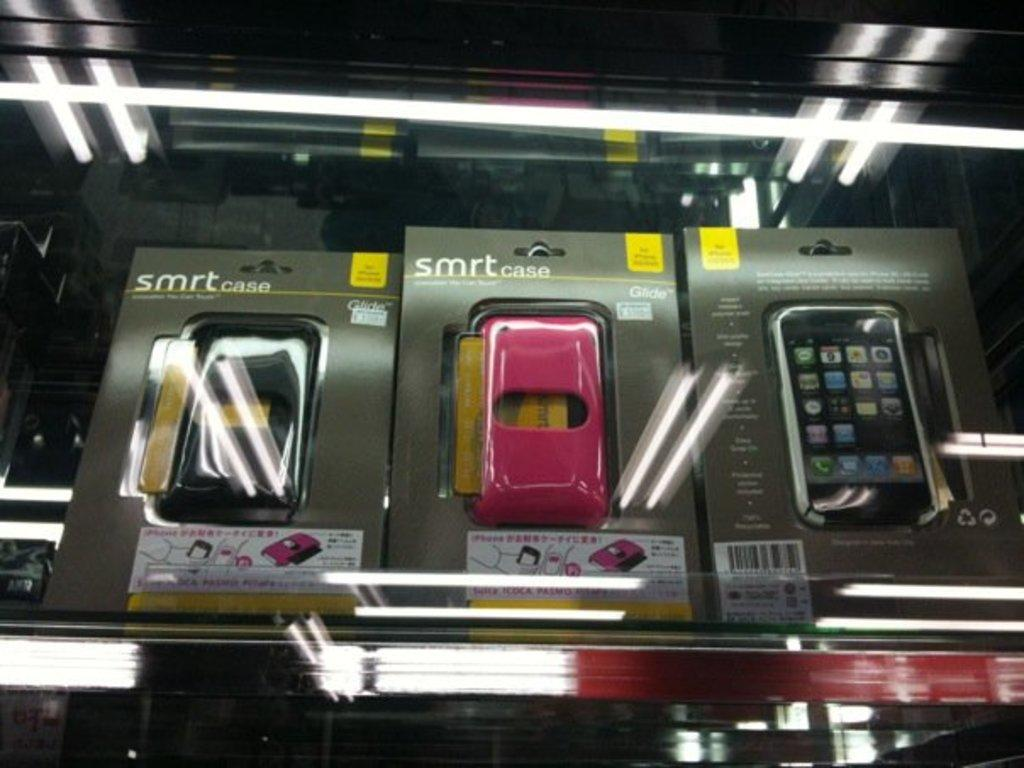<image>
Present a compact description of the photo's key features. A display case has three phone cases in it that say smrt case. 